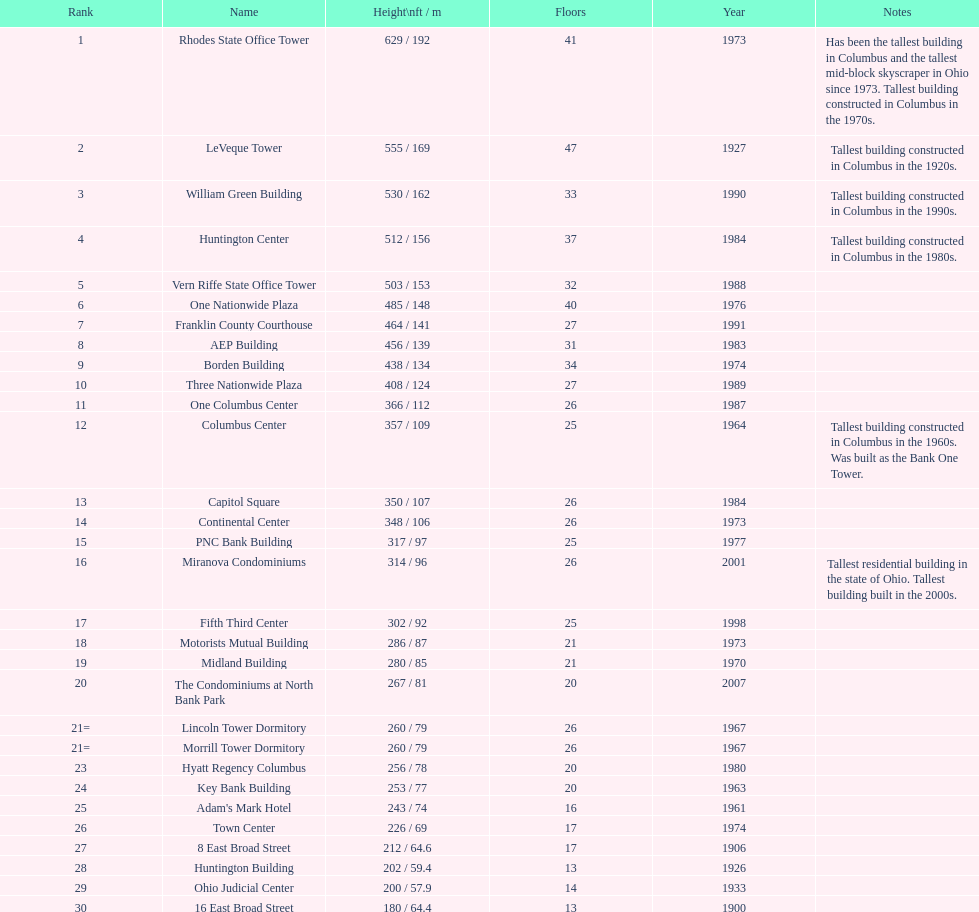Can you identify the tallest building in columbus? Rhodes State Office Tower. 